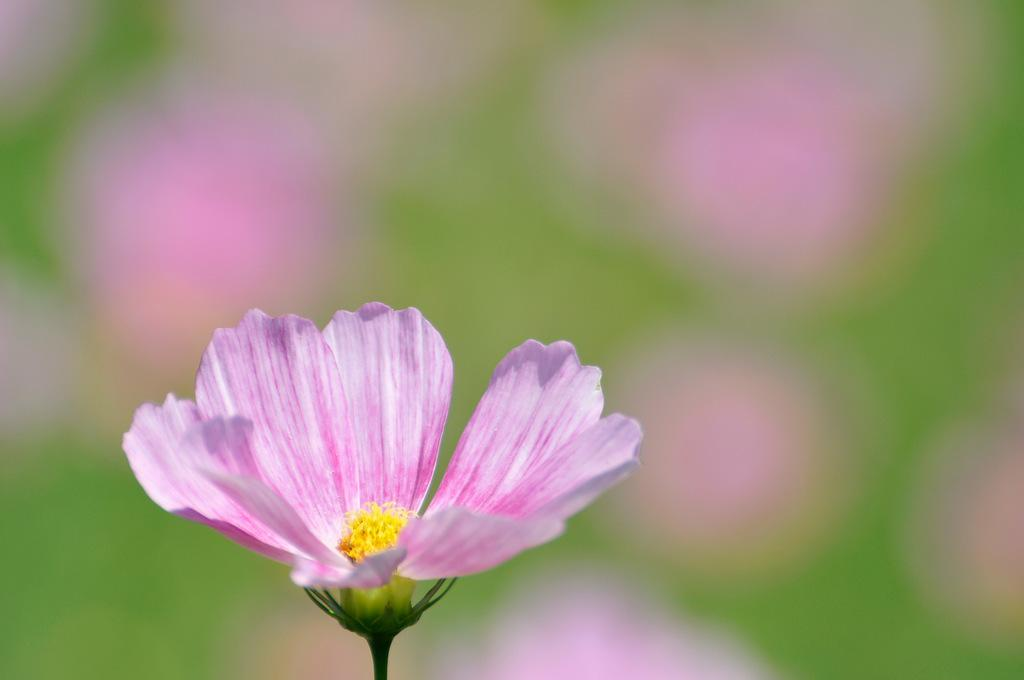What is the main subject of the image? There is a flower in the image. Can you describe the background of the image? The background of the image is blurred. What type of car can be seen driving through the flower in the image? There is no car present in the image; it features a flower with a blurred background. What musical instrument is being played by the flower in the image? There is no musical instrument or any indication of music in the image; it only features a flower with a blurred background. 